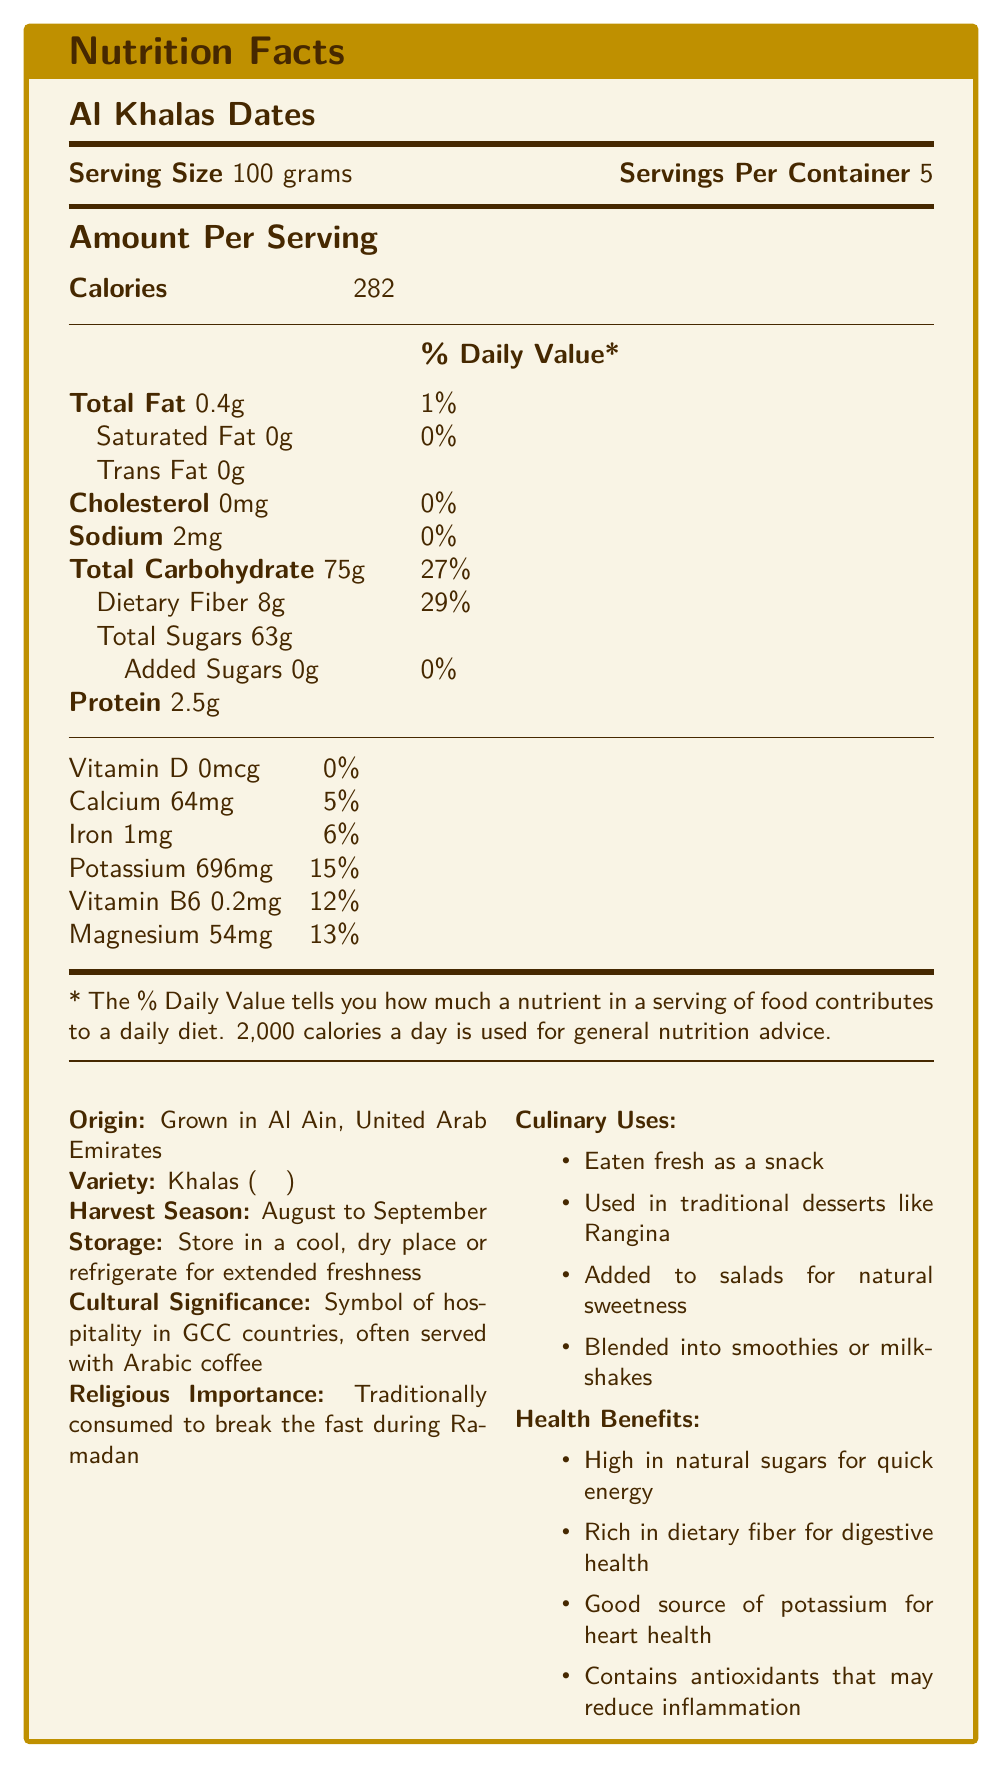what is the serving size of Al Khalas Dates? The document specifies that the serving size is 100 grams.
Answer: 100 grams how many calories are in one serving of Al Khalas Dates? The "Amount Per Serving" section lists 282 calories per serving.
Answer: 282 what is the total fat content in one serving? Under the "Total Fat" section, it states that one serving contains 0.4 grams of total fat.
Answer: 0.4g what is the dietary fiber content in one serving, and what percentage of the daily value does it represent? The dietary fiber content is listed as 8 grams, which is 29% of the daily value.
Answer: 8g, 29% how much potassium is in one serving of Al Khalas Dates? The document shows that one serving contains 696 mg of potassium.
Answer: 696mg what are some health benefits of Al Khalas Dates? The health benefits are listed in the "Health Benefits" section.
Answer: High in natural sugars for quick energy, rich in dietary fiber for digestive health, good source of potassium for heart health, contains antioxidants that may reduce inflammation what is the cultural significance of dates in GCC countries? The cultural significance is stated as dates being a symbol of hospitality in GCC countries and often being served with Arabic coffee.
Answer: Symbol of hospitality, often served with Arabic coffee in what variety are Al Khalas Dates categorized? The document mentions that the variety of dates is Khalas (خلاص).
Answer: Khalas (خلاص) when are Al Khalas Dates typically harvested? The harvest season for these dates is listed as August to September.
Answer: August to September what is the recommended method of storing Al Khalas Dates? The storage instructions specify to store the dates in a cool, dry place or refrigerate them for extended freshness.
Answer: Store in a cool, dry place or refrigerate for extended freshness how much iron is in one serving of Al Khalas Dates? The document lists 1 milligram of iron per serving.
Answer: 1mg which of the following is not a culinary use of Al Khalas Dates? A. Eaten fresh as a snack B. Used as a pizza topping C. Added to salads for natural sweetness D. Blended into smoothies or milkshakes The culinary uses listed do not include being used as a pizza topping.
Answer: B. Used as a pizza topping what is the total carbohydrate content in one serving, and how much of it is dietary fiber? A. 63g total, 29g fiber B. 75g total, 8g fiber C. 64g total, 5g fiber D. 75g total, 63g fiber The document states that the total carbohydrate content is 75 grams, of which 8 grams is dietary fiber.
Answer: B. 75g total, 8g fiber is there any trans fat in Al Khalas Dates? The document specifies that there is 0 grams of trans fat.
Answer: No are Al Khalas Dates traditionally consumed during Ramadan? The document mentions that dates are traditionally consumed to break the fast during Ramadan.
Answer: Yes summarize the main nutritional and cultural aspects of Al Khalas Dates from the document. This summary includes the key nutritional values, cultural significance, and health benefits stated in the document.
Answer: Al Khalas Dates, grown in Al Ain, UAE, are low in total fat and cholesterol, but high in carbohydrates, dietary fiber, and potassium. They are culturally significant in GCC countries, symbolizing hospitality and traditionally consumed during Ramadan. They can be eaten as snacks or used in various culinary creations and are stored in cool, dry places to maintain freshness. Health benefits include quick energy from natural sugars, digestive health from fiber, heart health support from potassium, and potential inflammation reduction thanks to antioxidants. what is the sodium content in one serving of Al Khalas Dates? The document lists that one serving contains 2 milligrams of sodium.
Answer: 2mg how many servings are there per container of Al Khalas Dates? The document specifies that there are 5 servings per container.
Answer: 5 how much added sugar is there in Al Khalas Dates? According to the document, there is 0 grams of added sugar.
Answer: 0g how do Al Khalas Dates help with heart health? The health benefits section states that they are a good source of potassium, which is beneficial for heart health.
Answer: Good source of potassium how many milligrams of calcium are in one serving of Al Khalas Dates? The document shows that each serving contains 64 milligrams of calcium.
Answer: 64mg what web address can I visit to purchase Al Khalas Dates? The document does not provide a website or any purchasing information.
Answer: Not enough information 